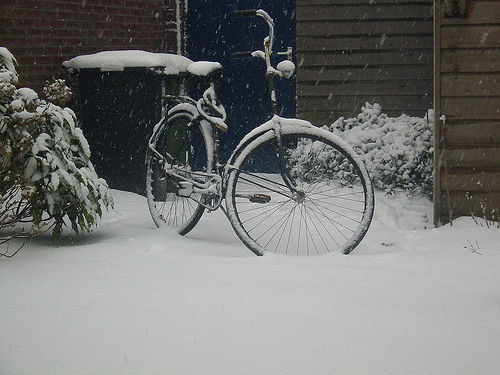What mood does this snowy scene with the bicycle evoke? The image evokes a quiet, peaceful mood, with the untouched snow suggesting a calm and undisturbed moment. The bicycle, blanketed in snow, adds a sense of stillness, as if the world around has paused. 